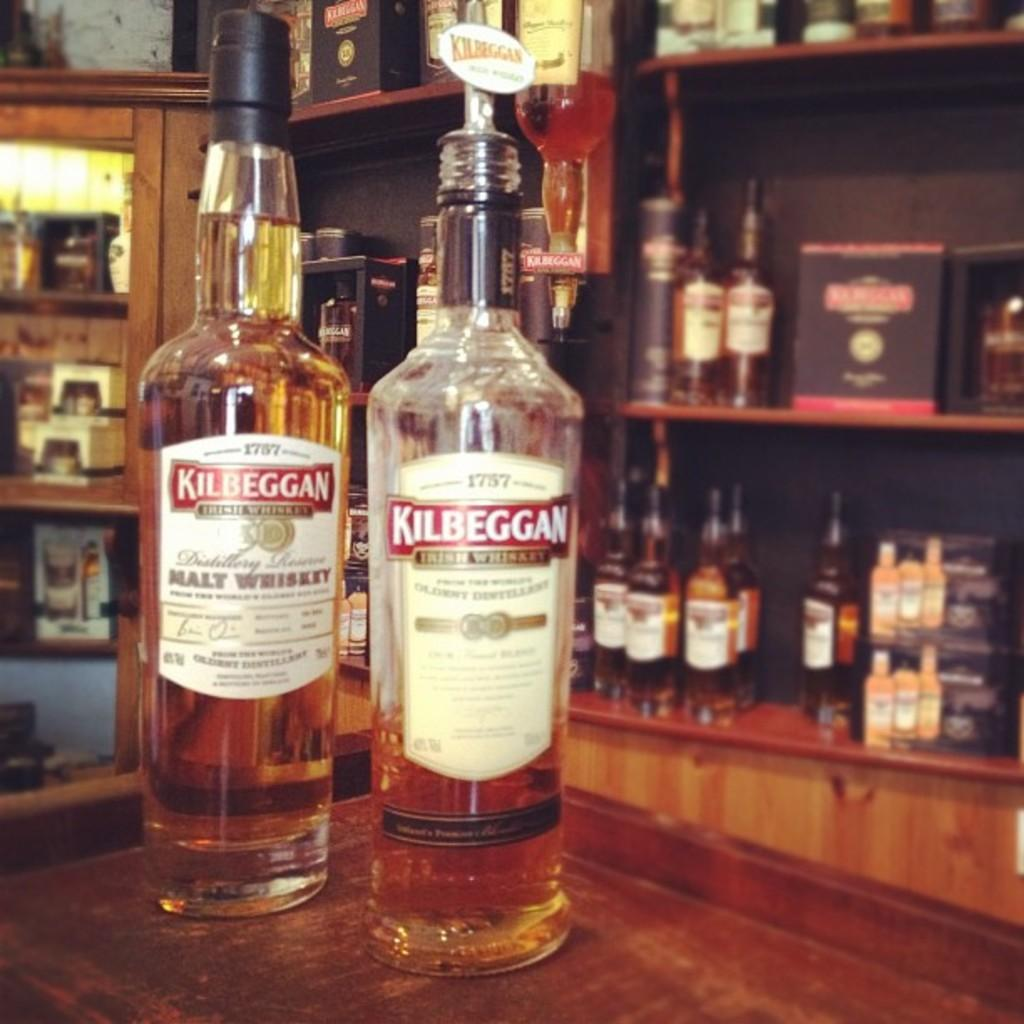<image>
Give a short and clear explanation of the subsequent image. Two bottles of kilbeggan on a bar counter 